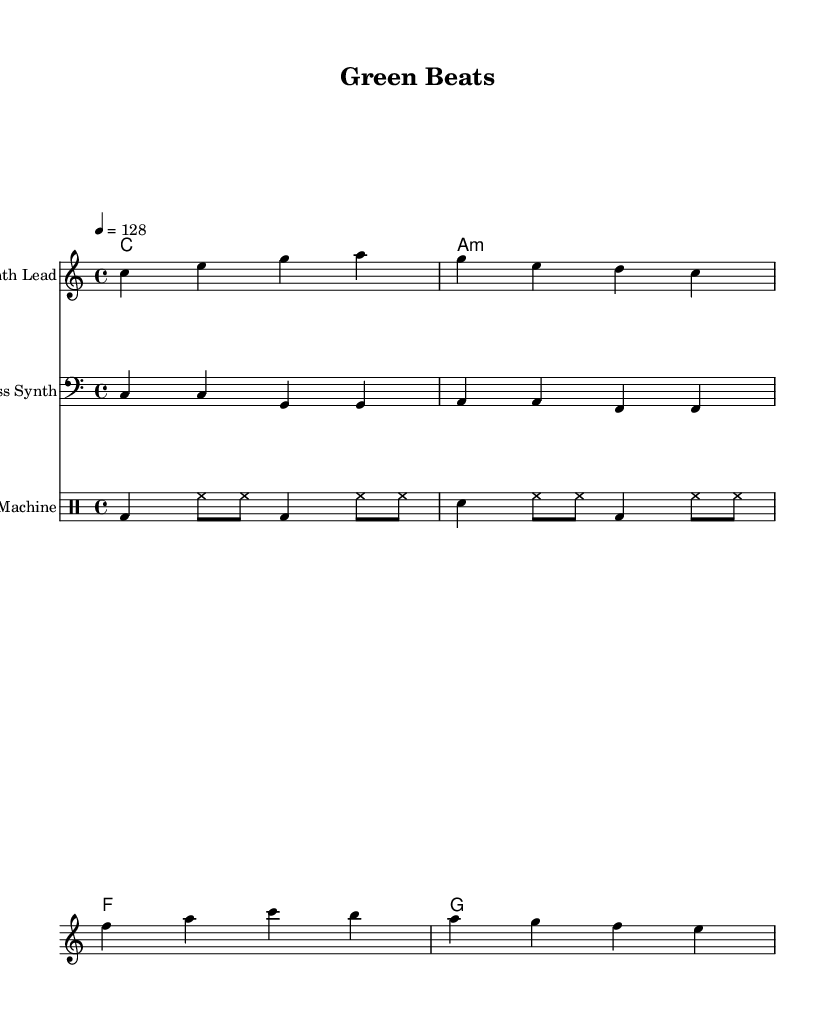What is the key signature of this music? The key signature indicated is C major, which is typically shown with no sharps or flats in the beginning of the staff.
Answer: C major What is the time signature of the piece? The time signature is indicated as 4/4, which means there are four beats in each measure and the quarter note receives one beat.
Answer: 4/4 What tempo is specified for this piece? The tempo is indicated as 128 beats per minute, which is stated in the score. This sets the pace for the performance of the music.
Answer: 128 How many measures are in the melody? By counting the separated groups of notes in the melody section, there are four measures shown in total across the staff.
Answer: 4 What is the instrument name for the melody played? The instrument name shown at the beginning of the staff for the melody line is "Synth Lead." This indicates the type of sound to be used for the melody.
Answer: Synth Lead Which chord is played in the last measure? The chord in the last measure is G, as identified in the chord names section below the staff, indicating the harmony for that measure.
Answer: G What are the lyrics associated with the melody? The lyrics given correspond to the melody, starting with "Green beats, plant-based treats," indicating the message aligned with the music's theme.
Answer: "Green beats, plant -- based treats." 